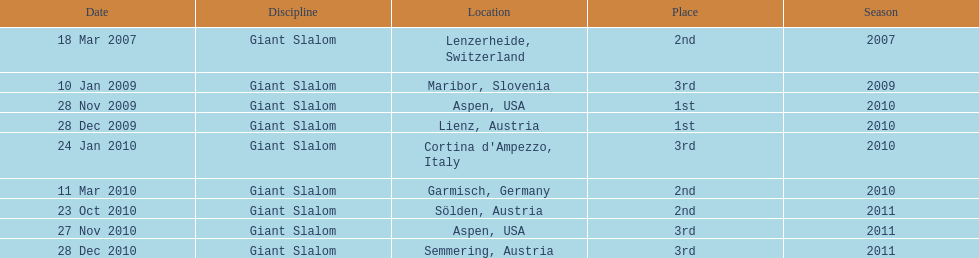What is the total number of her 2nd place finishes on the list? 3. 